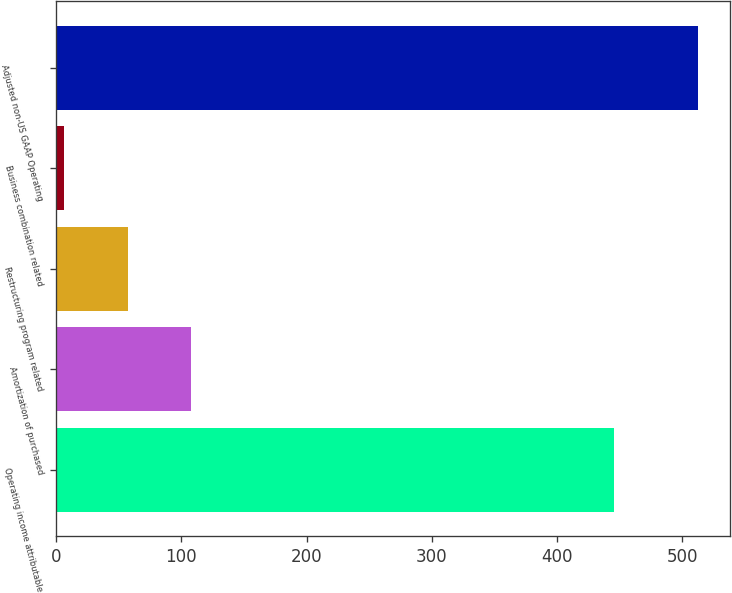Convert chart. <chart><loc_0><loc_0><loc_500><loc_500><bar_chart><fcel>Operating income attributable<fcel>Amortization of purchased<fcel>Restructuring program related<fcel>Business combination related<fcel>Adjusted non-US GAAP Operating<nl><fcel>445.6<fcel>108<fcel>57.4<fcel>6.8<fcel>512.8<nl></chart> 